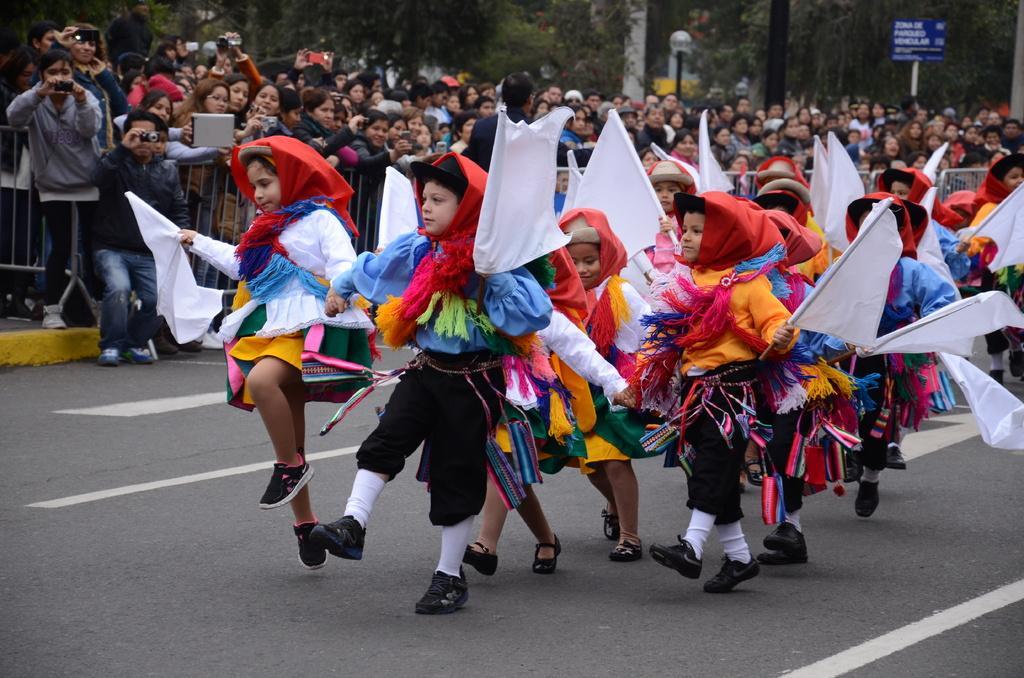Describe this image in one or two sentences. In this image we can see some group of persons wearing similar dresses holding some flags in their hands walking through the road and in the background of the image there are some persons standing near the fencing holding mobile phones, cameras in their hands, there are some trees and some boards. 